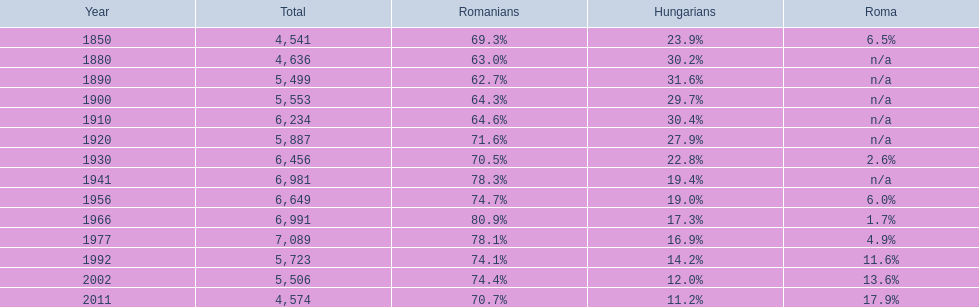1%, and what is the year prior to that? 1977. 